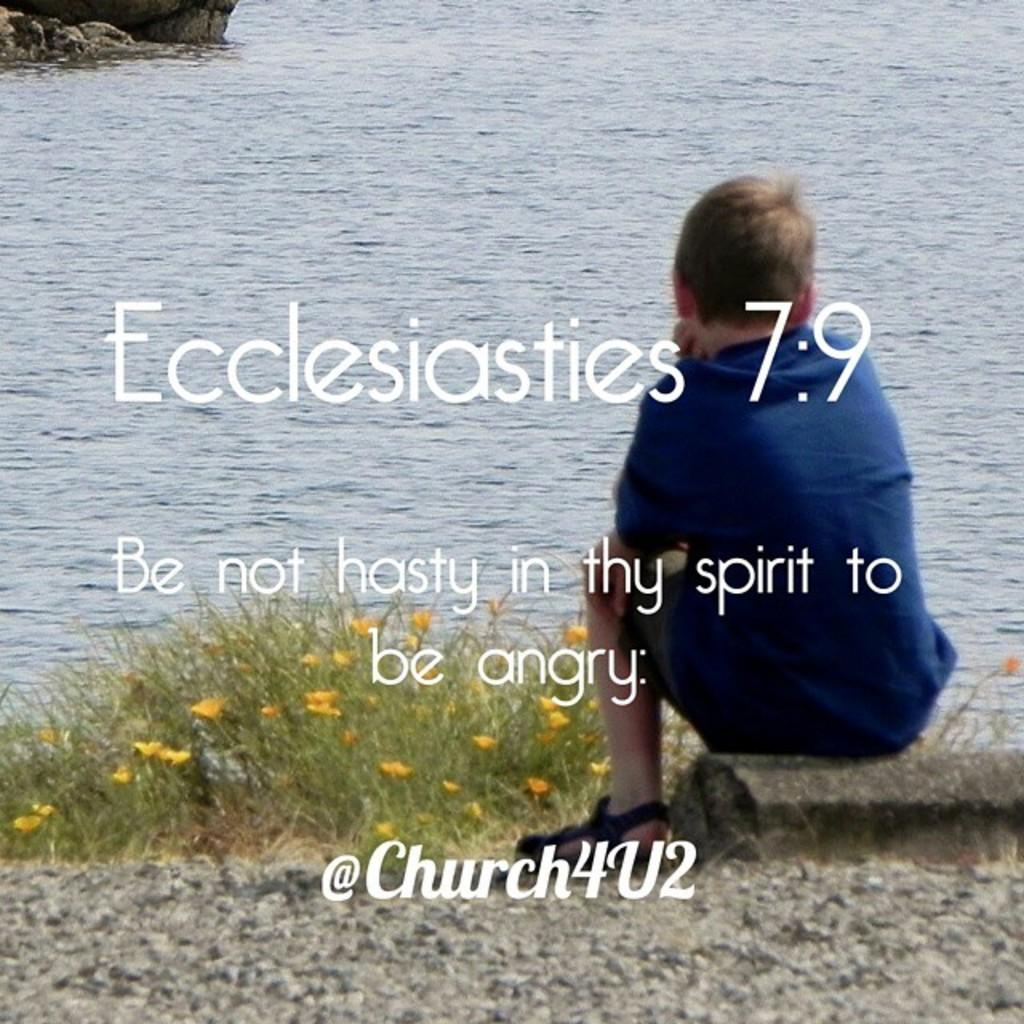What is the person in the image doing? The person is sitting in the image. What color is the dress the person is wearing? The person is wearing a blue dress. What can be seen in front of the person? There are yellow flowers in front of the person. What type of natural environment is visible in the image? There is grass and water visible in the image. What object can be seen in the image? There is a rock in the image. What type of knowledge is the person gaining from the boat in the image? There is no boat present in the image, so the person cannot gain knowledge from a boat. 